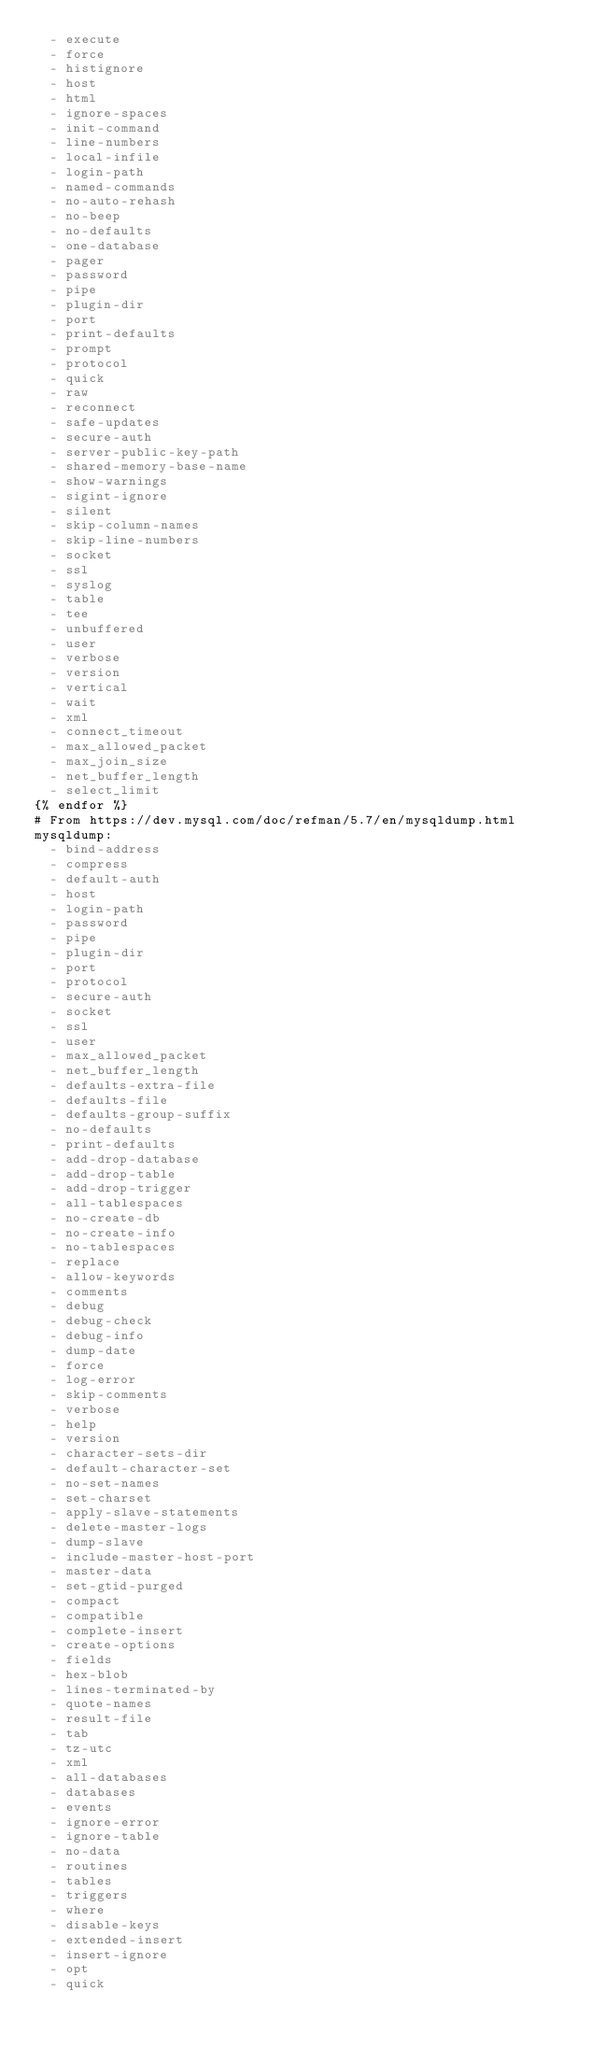Convert code to text. <code><loc_0><loc_0><loc_500><loc_500><_YAML_>  - execute
  - force
  - histignore
  - host
  - html
  - ignore-spaces
  - init-command
  - line-numbers
  - local-infile
  - login-path
  - named-commands
  - no-auto-rehash
  - no-beep
  - no-defaults
  - one-database
  - pager
  - password
  - pipe
  - plugin-dir
  - port
  - print-defaults
  - prompt
  - protocol
  - quick
  - raw
  - reconnect
  - safe-updates
  - secure-auth
  - server-public-key-path
  - shared-memory-base-name
  - show-warnings
  - sigint-ignore
  - silent
  - skip-column-names
  - skip-line-numbers
  - socket
  - ssl
  - syslog
  - table
  - tee
  - unbuffered
  - user
  - verbose
  - version
  - vertical
  - wait
  - xml
  - connect_timeout
  - max_allowed_packet
  - max_join_size
  - net_buffer_length
  - select_limit
{% endfor %}
# From https://dev.mysql.com/doc/refman/5.7/en/mysqldump.html
mysqldump:
  - bind-address
  - compress
  - default-auth
  - host
  - login-path
  - password
  - pipe
  - plugin-dir
  - port
  - protocol
  - secure-auth
  - socket
  - ssl
  - user
  - max_allowed_packet
  - net_buffer_length
  - defaults-extra-file
  - defaults-file
  - defaults-group-suffix
  - no-defaults
  - print-defaults
  - add-drop-database
  - add-drop-table
  - add-drop-trigger
  - all-tablespaces
  - no-create-db
  - no-create-info
  - no-tablespaces
  - replace
  - allow-keywords
  - comments
  - debug
  - debug-check
  - debug-info
  - dump-date
  - force
  - log-error
  - skip-comments
  - verbose
  - help
  - version
  - character-sets-dir
  - default-character-set
  - no-set-names
  - set-charset
  - apply-slave-statements
  - delete-master-logs
  - dump-slave
  - include-master-host-port
  - master-data
  - set-gtid-purged
  - compact
  - compatible
  - complete-insert
  - create-options
  - fields
  - hex-blob
  - lines-terminated-by
  - quote-names
  - result-file
  - tab
  - tz-utc
  - xml
  - all-databases
  - databases
  - events
  - ignore-error
  - ignore-table
  - no-data
  - routines
  - tables
  - triggers
  - where
  - disable-keys
  - extended-insert
  - insert-ignore
  - opt
  - quick</code> 